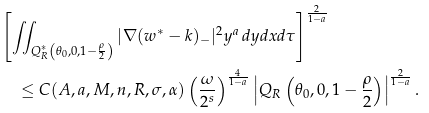Convert formula to latex. <formula><loc_0><loc_0><loc_500><loc_500>& \left [ \iint _ { Q ^ { \ast } _ { R } \left ( \theta _ { 0 } , 0 , 1 - \frac { \rho } { 2 } \right ) } | \nabla ( w ^ { \ast } - k ) _ { - } | ^ { 2 } y ^ { a } \, d y d x d \tau \right ] ^ { \frac { 2 } { 1 - a } } \\ & \quad \leq C ( A , a , M , n , R , \sigma , \alpha ) \left ( \frac { \omega } { 2 ^ { s } } \right ) ^ { \frac { 4 } { 1 - a } } \left | Q _ { R } \left ( \theta _ { 0 } , 0 , 1 - \frac { \rho } { 2 } \right ) \right | ^ { \frac { 2 } { 1 - a } } .</formula> 